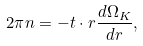<formula> <loc_0><loc_0><loc_500><loc_500>2 \pi n = - t \cdot r \frac { d \Omega _ { K } } { d r } ,</formula> 